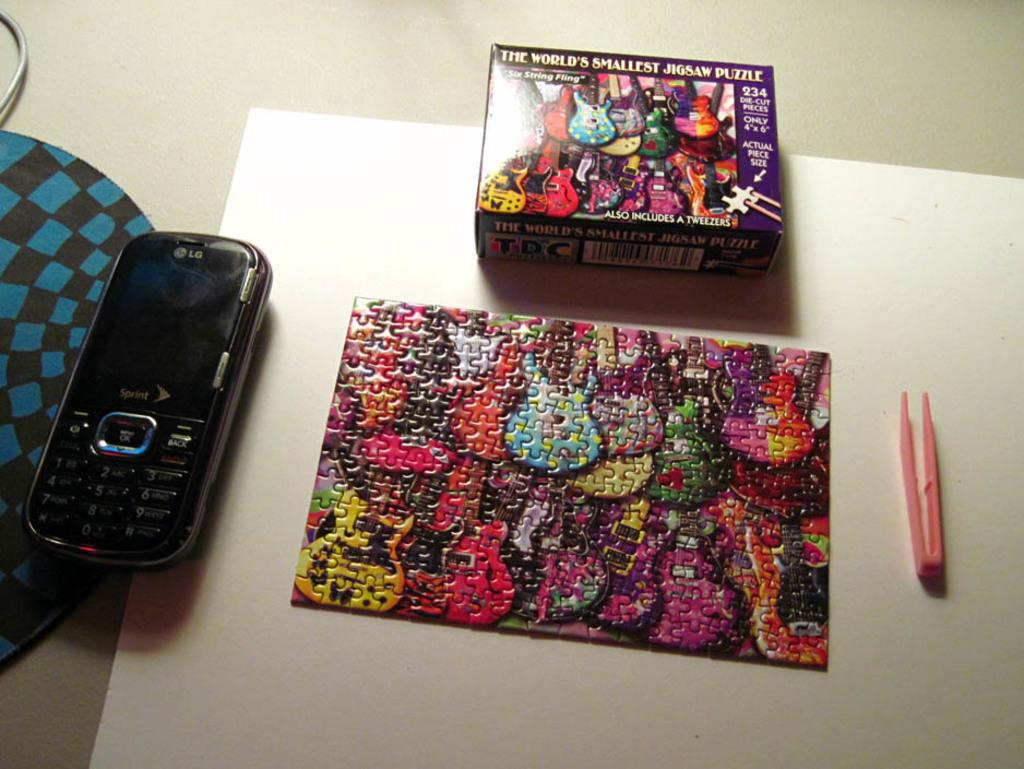Provide a one-sentence caption for the provided image. An abstract guitar painting puzzle completed by a pen and the puzzle box with a Sprint cellphone beside the puzzle. 